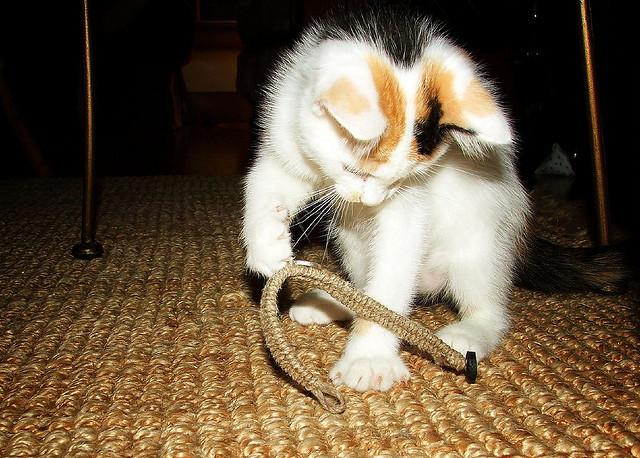What color is the carpet?
Give a very brief answer. Brown. Is this an adult cat?
Keep it brief. No. What sort of animal is present in the scene?
Keep it brief. Cat. Is the cat multi-colored?
Answer briefly. Yes. What color is the photo?
Be succinct. White. Is the cat playing?
Quick response, please. Yes. 